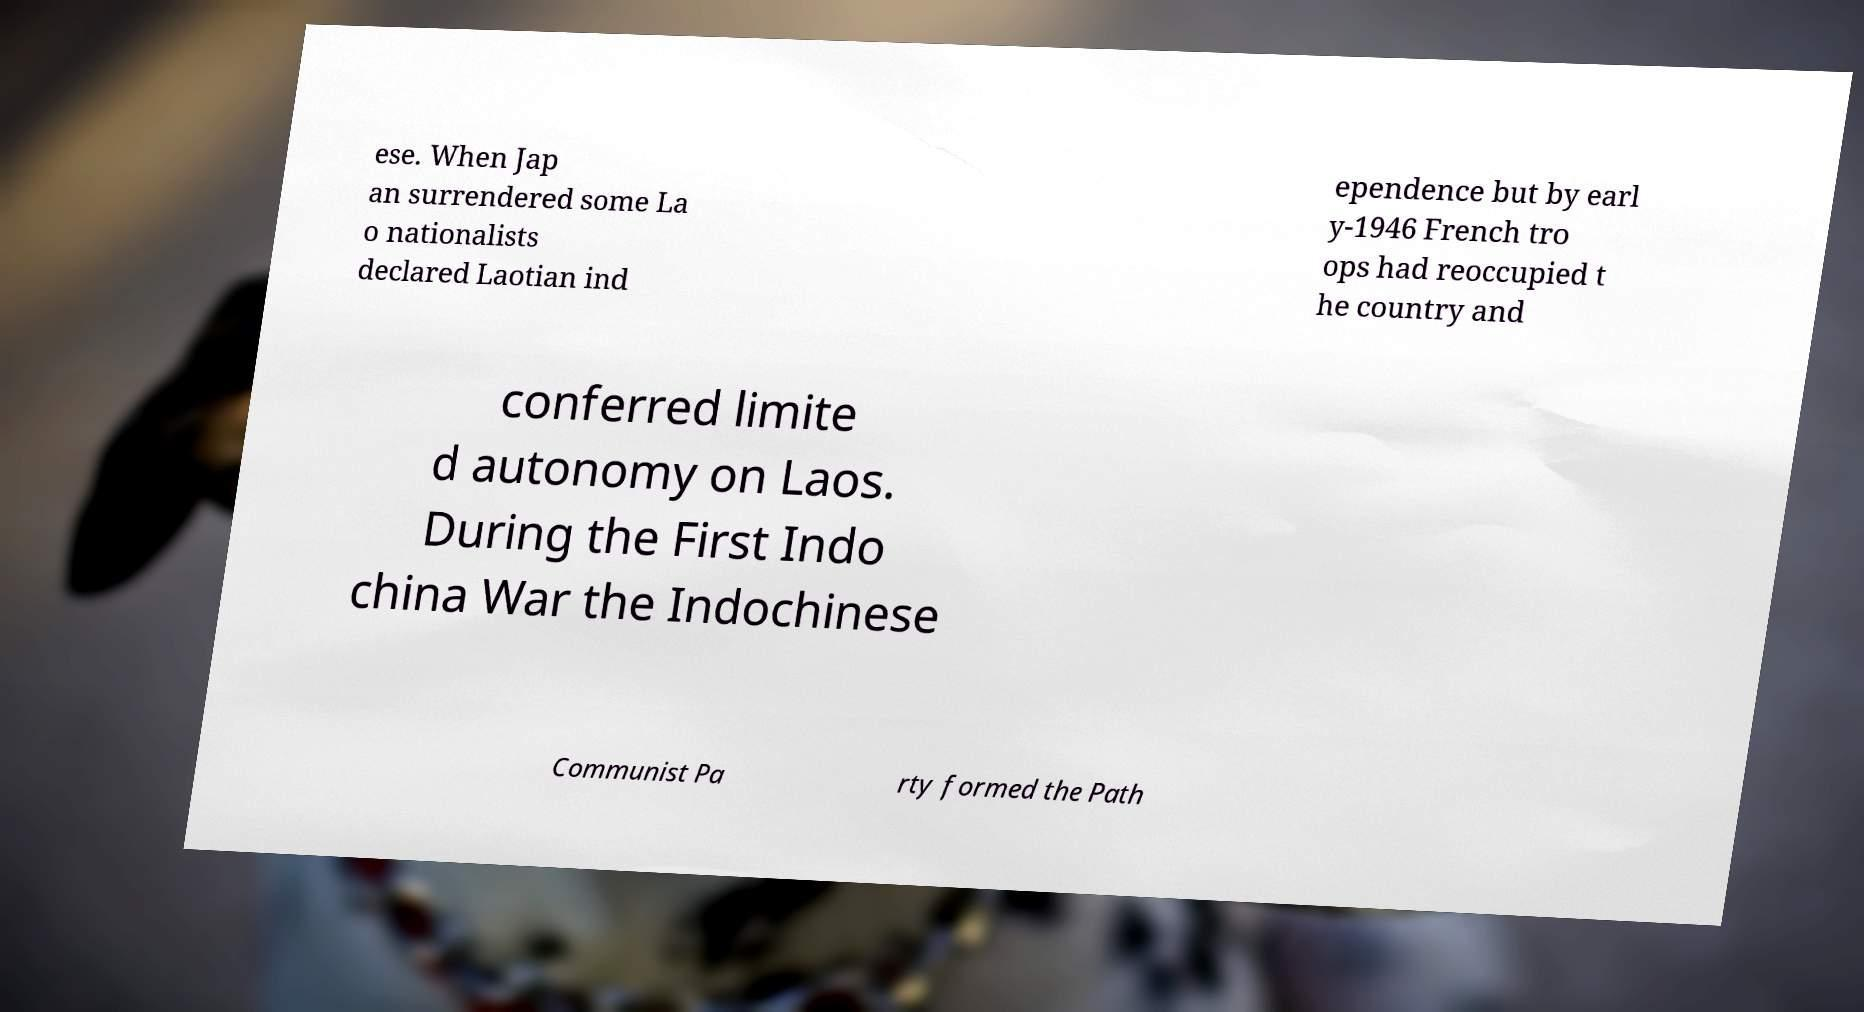There's text embedded in this image that I need extracted. Can you transcribe it verbatim? ese. When Jap an surrendered some La o nationalists declared Laotian ind ependence but by earl y-1946 French tro ops had reoccupied t he country and conferred limite d autonomy on Laos. During the First Indo china War the Indochinese Communist Pa rty formed the Path 